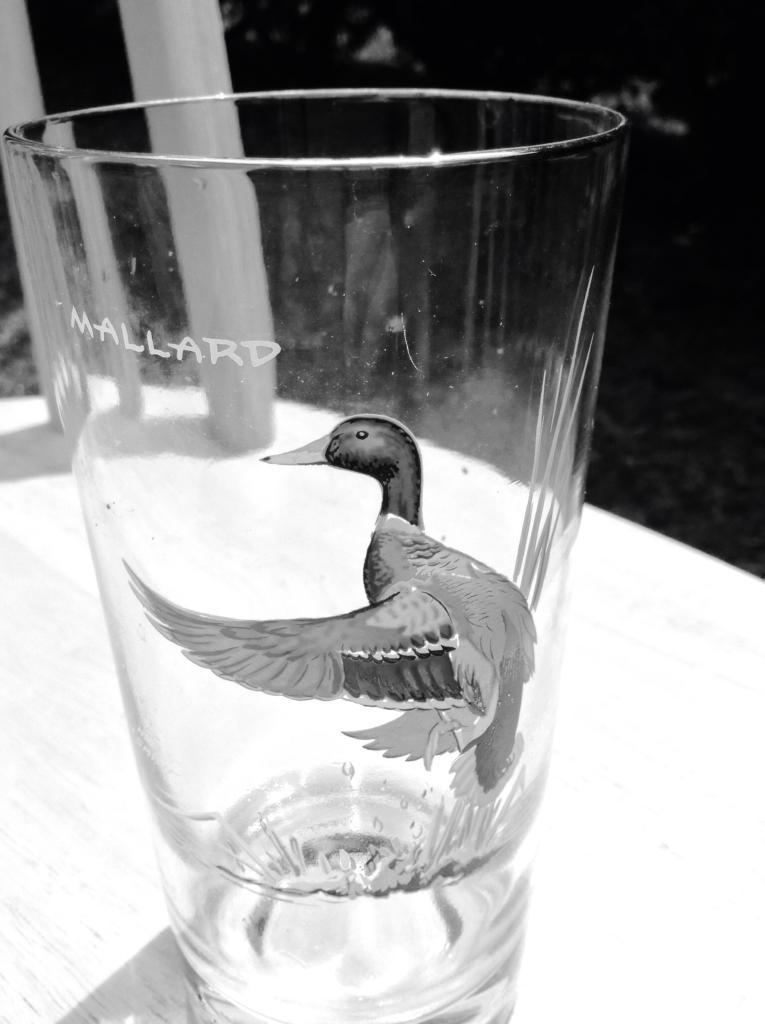What is the main object in the image? There is a glass with a design in the image. Where is the glass located? The glass is on a table. What is the color scheme of the image? The image is black and white in color. How many yams are visible in the image? There are no yams present in the image. What angle is the glass positioned at in the image? The angle of the glass cannot be determined from the image, as it is not mentioned in the provided facts. 